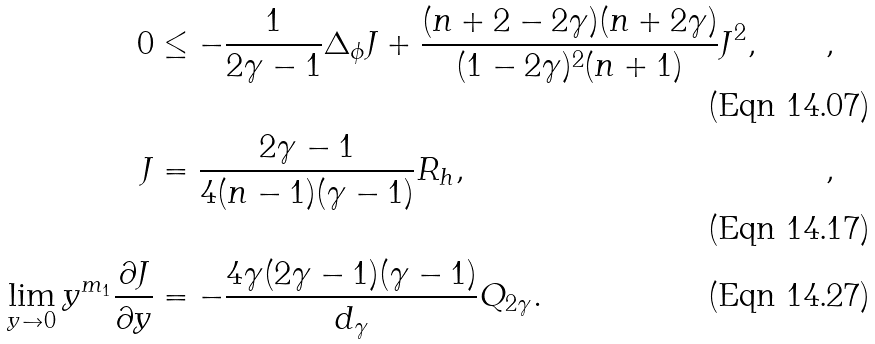<formula> <loc_0><loc_0><loc_500><loc_500>0 & \leq - \frac { 1 } { 2 \gamma - 1 } \Delta _ { \phi } J + \frac { ( n + 2 - 2 \gamma ) ( n + 2 \gamma ) } { ( 1 - 2 \gamma ) ^ { 2 } ( n + 1 ) } J ^ { 2 } , & \quad , \\ J & = \frac { 2 \gamma - 1 } { 4 ( n - 1 ) ( \gamma - 1 ) } R _ { h } , & \quad , \\ \lim _ { y \to 0 } y ^ { m _ { 1 } } \frac { \partial J } { \partial y } & = - \frac { 4 \gamma ( 2 \gamma - 1 ) ( \gamma - 1 ) } { d _ { \gamma } } Q _ { 2 \gamma } .</formula> 